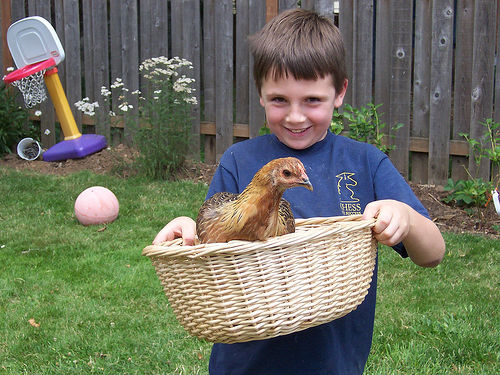<image>
Is there a chicken in the basket? Yes. The chicken is contained within or inside the basket, showing a containment relationship. Is the boy behind the chicken? Yes. From this viewpoint, the boy is positioned behind the chicken, with the chicken partially or fully occluding the boy. 